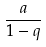Convert formula to latex. <formula><loc_0><loc_0><loc_500><loc_500>\frac { a } { 1 - q }</formula> 